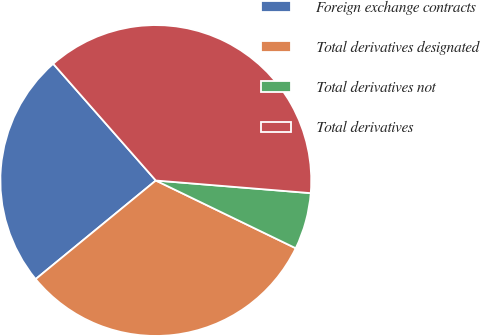Convert chart. <chart><loc_0><loc_0><loc_500><loc_500><pie_chart><fcel>Foreign exchange contracts<fcel>Total derivatives designated<fcel>Total derivatives not<fcel>Total derivatives<nl><fcel>24.46%<fcel>31.89%<fcel>5.88%<fcel>37.77%<nl></chart> 